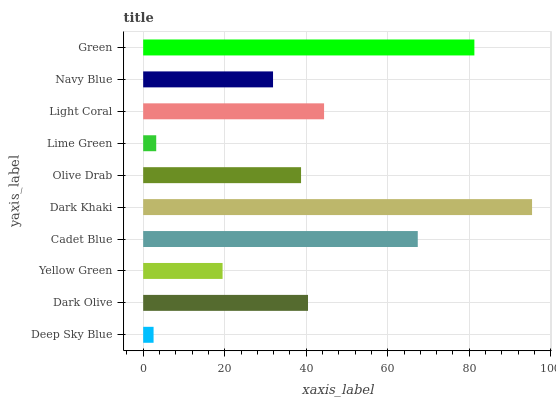Is Deep Sky Blue the minimum?
Answer yes or no. Yes. Is Dark Khaki the maximum?
Answer yes or no. Yes. Is Dark Olive the minimum?
Answer yes or no. No. Is Dark Olive the maximum?
Answer yes or no. No. Is Dark Olive greater than Deep Sky Blue?
Answer yes or no. Yes. Is Deep Sky Blue less than Dark Olive?
Answer yes or no. Yes. Is Deep Sky Blue greater than Dark Olive?
Answer yes or no. No. Is Dark Olive less than Deep Sky Blue?
Answer yes or no. No. Is Dark Olive the high median?
Answer yes or no. Yes. Is Olive Drab the low median?
Answer yes or no. Yes. Is Olive Drab the high median?
Answer yes or no. No. Is Yellow Green the low median?
Answer yes or no. No. 